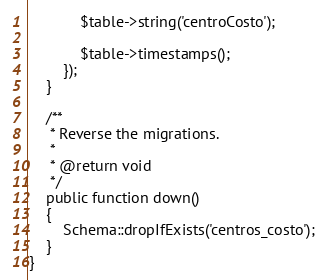<code> <loc_0><loc_0><loc_500><loc_500><_PHP_>            $table->string('centroCosto');
            
            $table->timestamps();
        });
    }

    /**
     * Reverse the migrations.
     *
     * @return void
     */
    public function down()
    {
        Schema::dropIfExists('centros_costo');
    }
}
</code> 